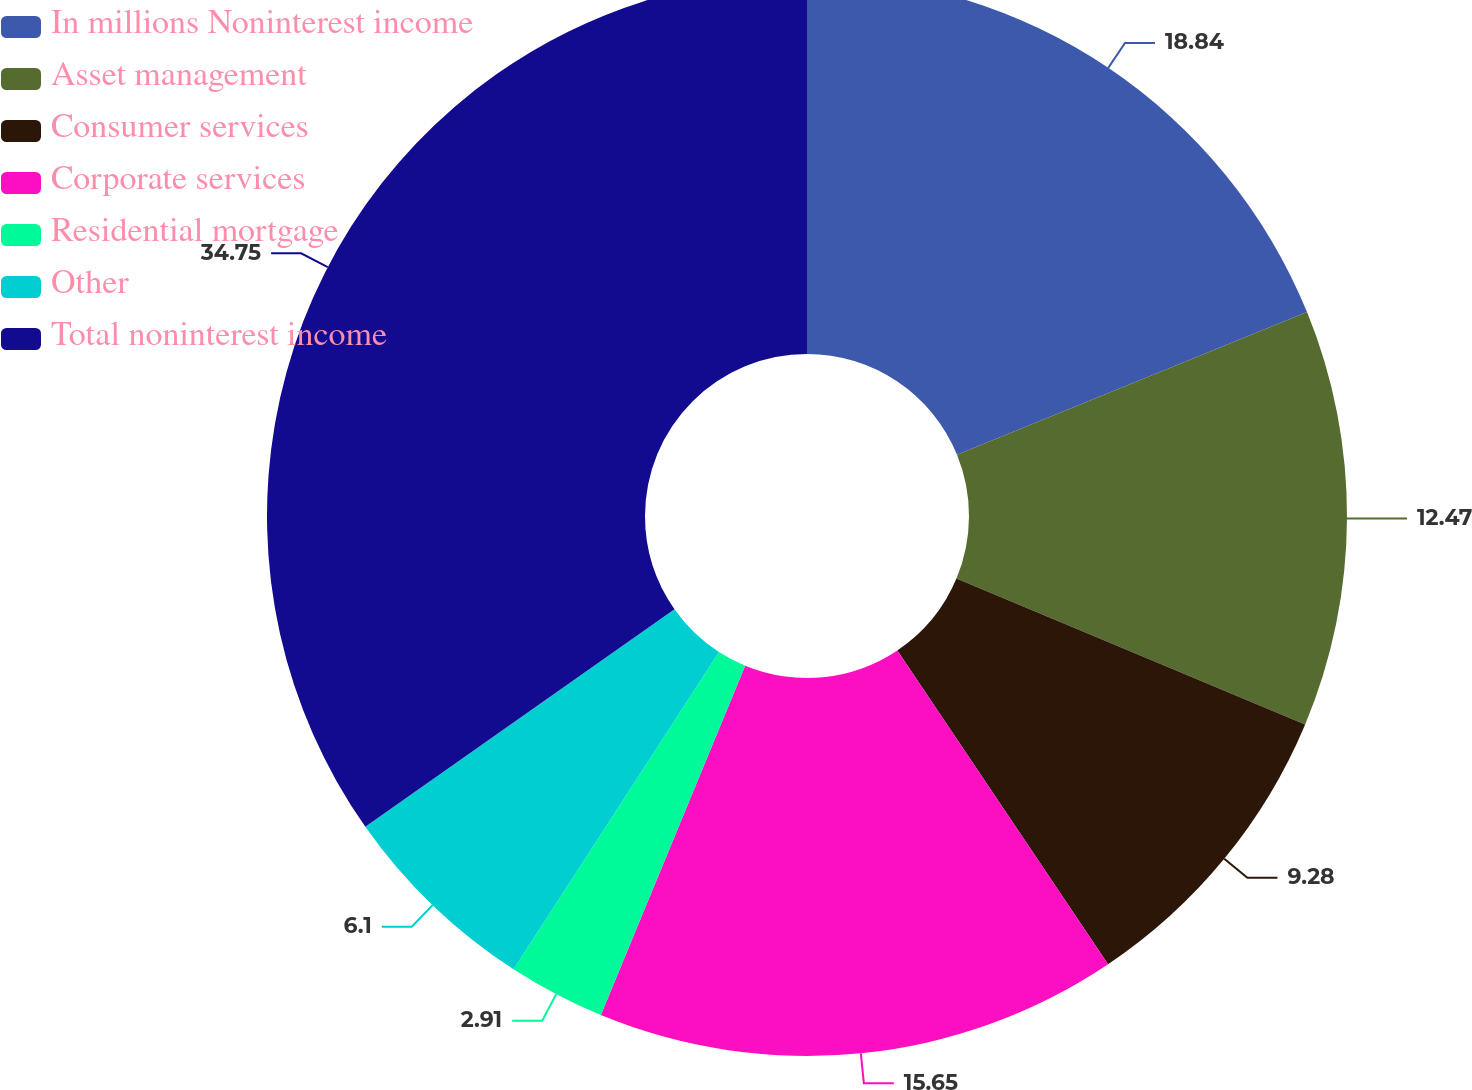<chart> <loc_0><loc_0><loc_500><loc_500><pie_chart><fcel>In millions Noninterest income<fcel>Asset management<fcel>Consumer services<fcel>Corporate services<fcel>Residential mortgage<fcel>Other<fcel>Total noninterest income<nl><fcel>18.84%<fcel>12.47%<fcel>9.28%<fcel>15.65%<fcel>2.91%<fcel>6.1%<fcel>34.76%<nl></chart> 